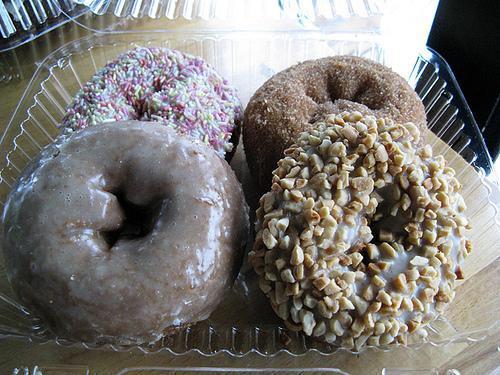How many donuts are there?
Give a very brief answer. 4. How many ovens in this image have a window on their door?
Give a very brief answer. 0. 